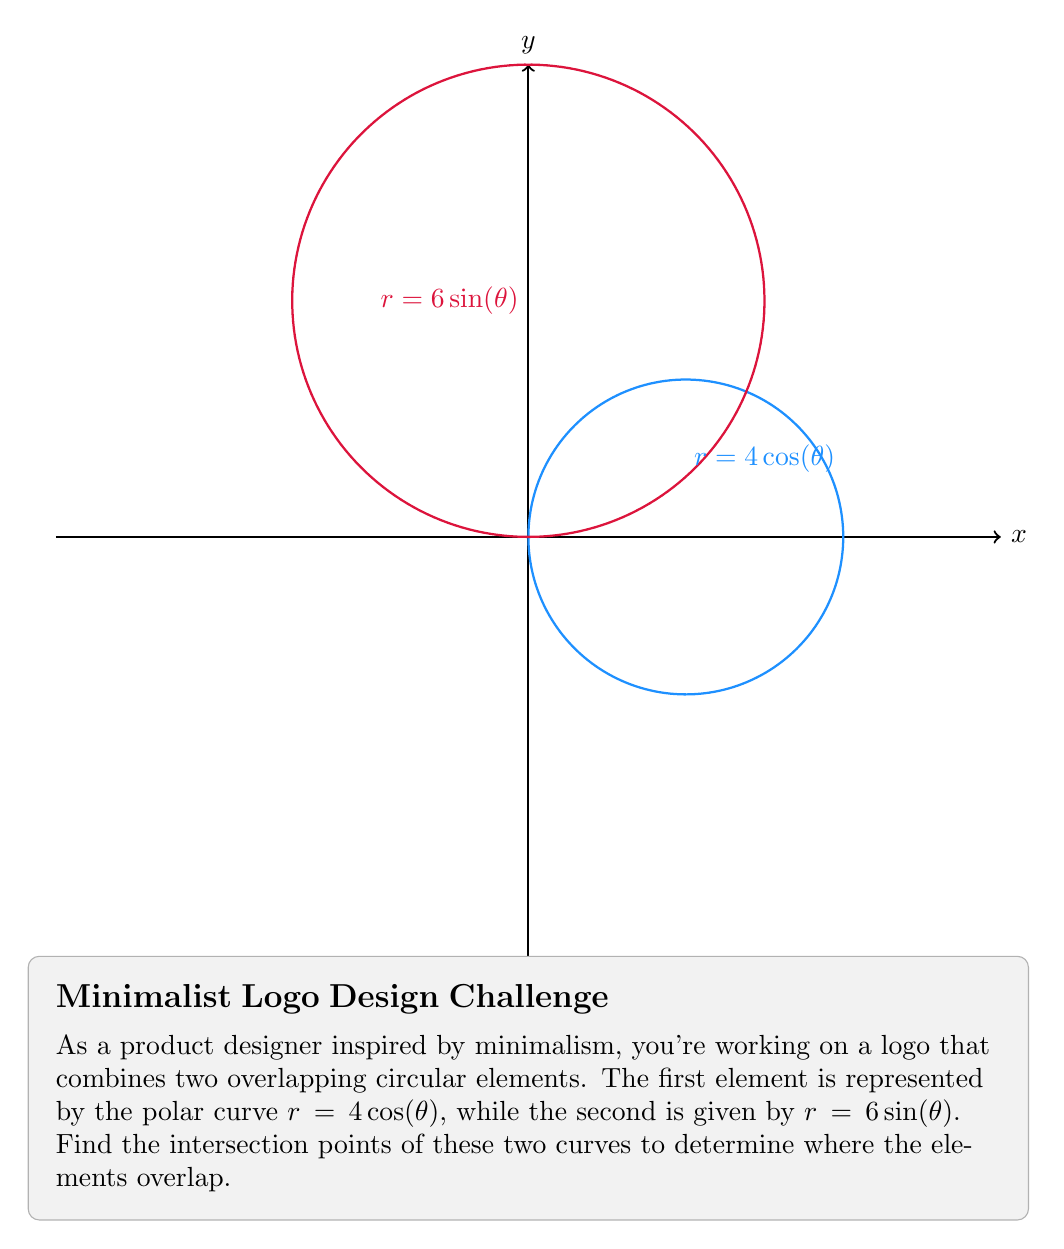Can you solve this math problem? To find the intersection points, we need to solve the equation:

$$4\cos(\theta) = 6\sin(\theta)$$

Step 1: Divide both sides by $\cos(\theta)$ (assuming $\cos(\theta) \neq 0$):

$$4 = 6\tan(\theta)$$

Step 2: Solve for $\theta$:

$$\tan(\theta) = \frac{2}{3}$$

$$\theta = \arctan\left(\frac{2}{3}\right) \approx 0.5880\text{ radians}$$

Step 3: Due to the symmetry of sine and cosine functions, there will be four solutions in the interval $[0, 2\pi)$:

$$\theta_1 = 0.5880$$
$$\theta_2 = \pi - 0.5880 = 2.5536$$
$$\theta_3 = \pi + 0.5880 = 3.7296$$
$$\theta_4 = 2\pi - 0.5880 = 5.6952$$

Step 4: Calculate the $r$ values for these $\theta$ values using either equation:

$$r = 4\cos(0.5880) = 6\sin(0.5880) \approx 3.2$$

Step 5: Convert to Cartesian coordinates:

$$(x_1, y_1) = (r\cos(\theta_1), r\sin(\theta_1)) \approx (2.56, 1.92)$$
$$(x_2, y_2) = (r\cos(\theta_2), r\sin(\theta_2)) \approx (-2.56, 1.92)$$
$$(x_3, y_3) = (r\cos(\theta_3), r\sin(\theta_3)) \approx (-2.56, -1.92)$$
$$(x_4, y_4) = (r\cos(\theta_4), r\sin(\theta_4)) \approx (2.56, -1.92)$$
Answer: $(\pm 2.56, \pm 1.92)$ 